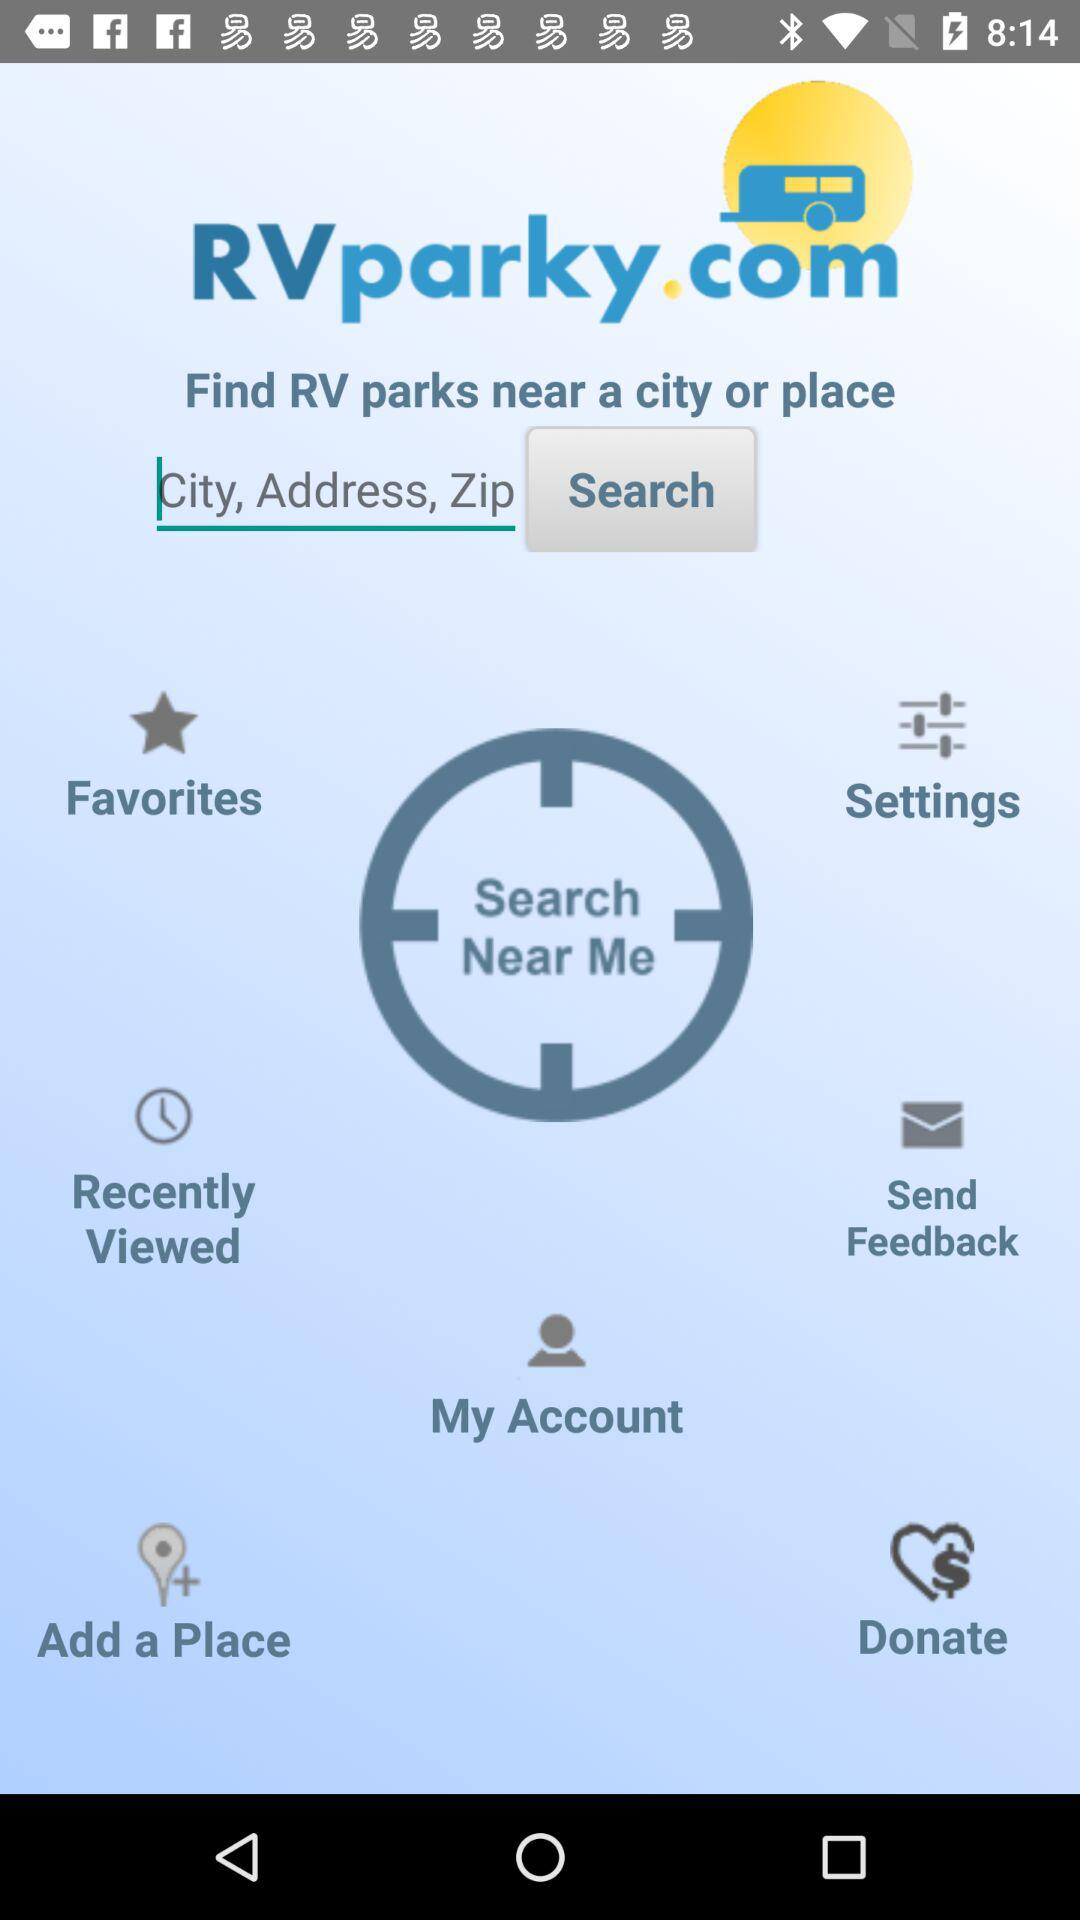What is the app name? The app name is RVparky. 